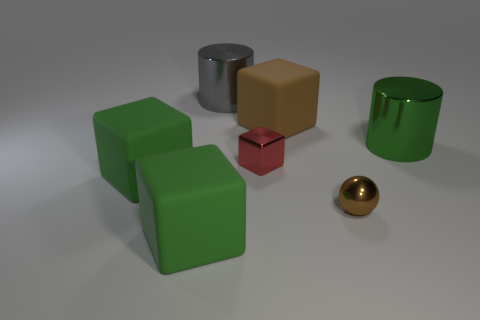Are there fewer gray shiny things that are on the right side of the brown sphere than red shiny cubes to the right of the red cube?
Provide a short and direct response. No. How many other objects are the same size as the brown sphere?
Your answer should be compact. 1. Are the small brown thing and the green block behind the brown metal sphere made of the same material?
Offer a very short reply. No. What number of things are either cylinders that are on the left side of the ball or small metallic objects that are to the left of the small brown metal ball?
Ensure brevity in your answer.  2. The metal sphere is what color?
Offer a terse response. Brown. Is the number of gray cylinders on the right side of the large brown object less than the number of brown rubber blocks?
Give a very brief answer. Yes. Is there any other thing that has the same shape as the big brown matte thing?
Make the answer very short. Yes. Is there a matte thing?
Your answer should be very brief. Yes. Are there fewer small yellow rubber things than small brown things?
Make the answer very short. Yes. What number of big green cubes are made of the same material as the brown block?
Give a very brief answer. 2. 